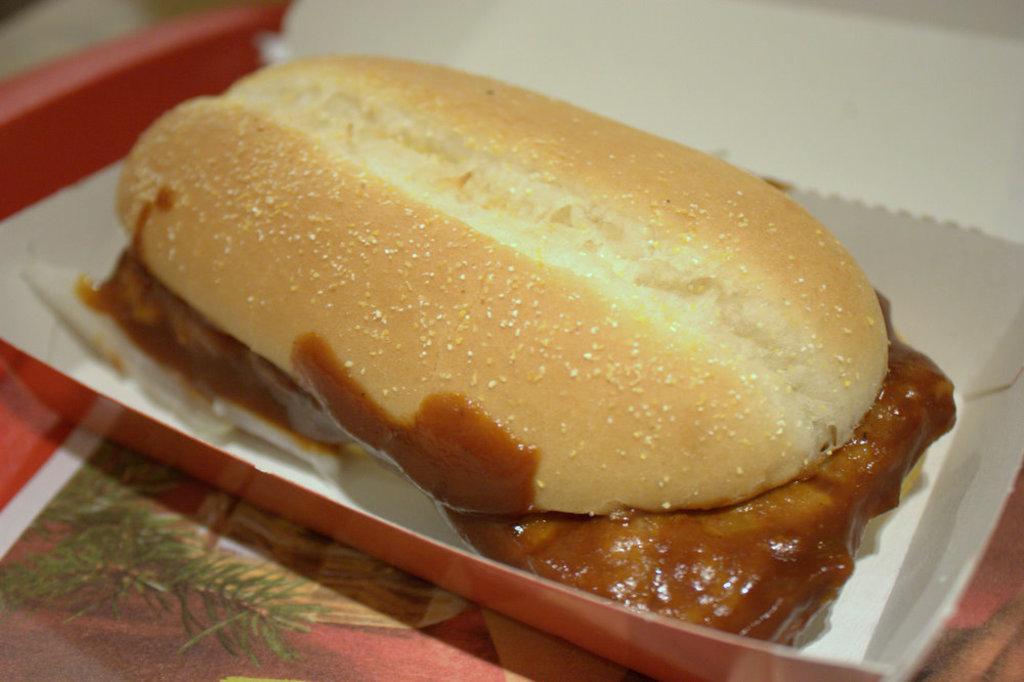In one or two sentences, can you explain what this image depicts? In this image, we can see a food item on the surface. 